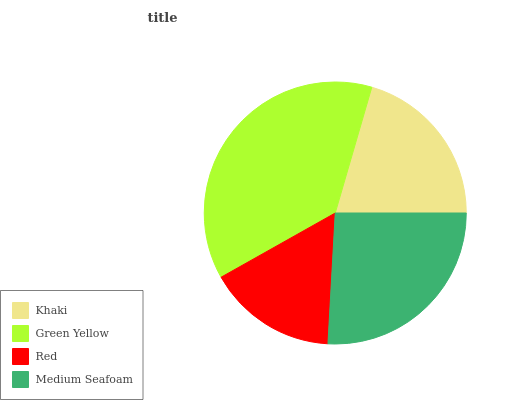Is Red the minimum?
Answer yes or no. Yes. Is Green Yellow the maximum?
Answer yes or no. Yes. Is Green Yellow the minimum?
Answer yes or no. No. Is Red the maximum?
Answer yes or no. No. Is Green Yellow greater than Red?
Answer yes or no. Yes. Is Red less than Green Yellow?
Answer yes or no. Yes. Is Red greater than Green Yellow?
Answer yes or no. No. Is Green Yellow less than Red?
Answer yes or no. No. Is Medium Seafoam the high median?
Answer yes or no. Yes. Is Khaki the low median?
Answer yes or no. Yes. Is Red the high median?
Answer yes or no. No. Is Green Yellow the low median?
Answer yes or no. No. 